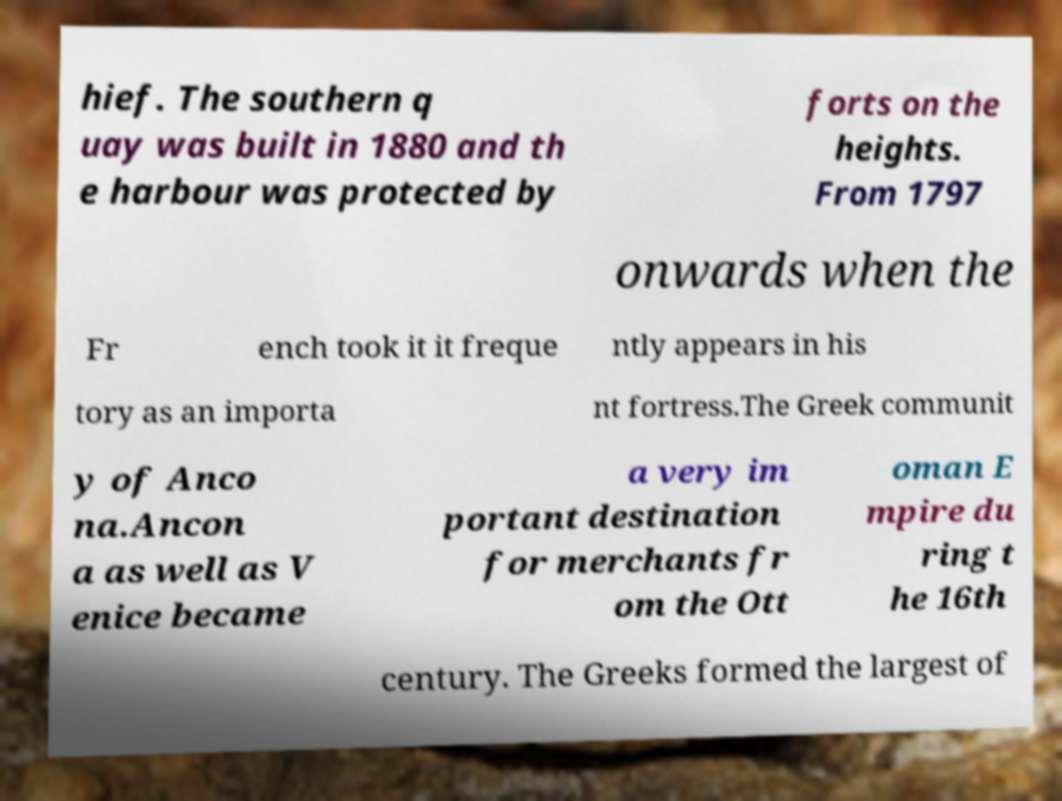Please identify and transcribe the text found in this image. hief. The southern q uay was built in 1880 and th e harbour was protected by forts on the heights. From 1797 onwards when the Fr ench took it it freque ntly appears in his tory as an importa nt fortress.The Greek communit y of Anco na.Ancon a as well as V enice became a very im portant destination for merchants fr om the Ott oman E mpire du ring t he 16th century. The Greeks formed the largest of 